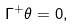Convert formula to latex. <formula><loc_0><loc_0><loc_500><loc_500>\Gamma ^ { + } \theta = 0 ,</formula> 